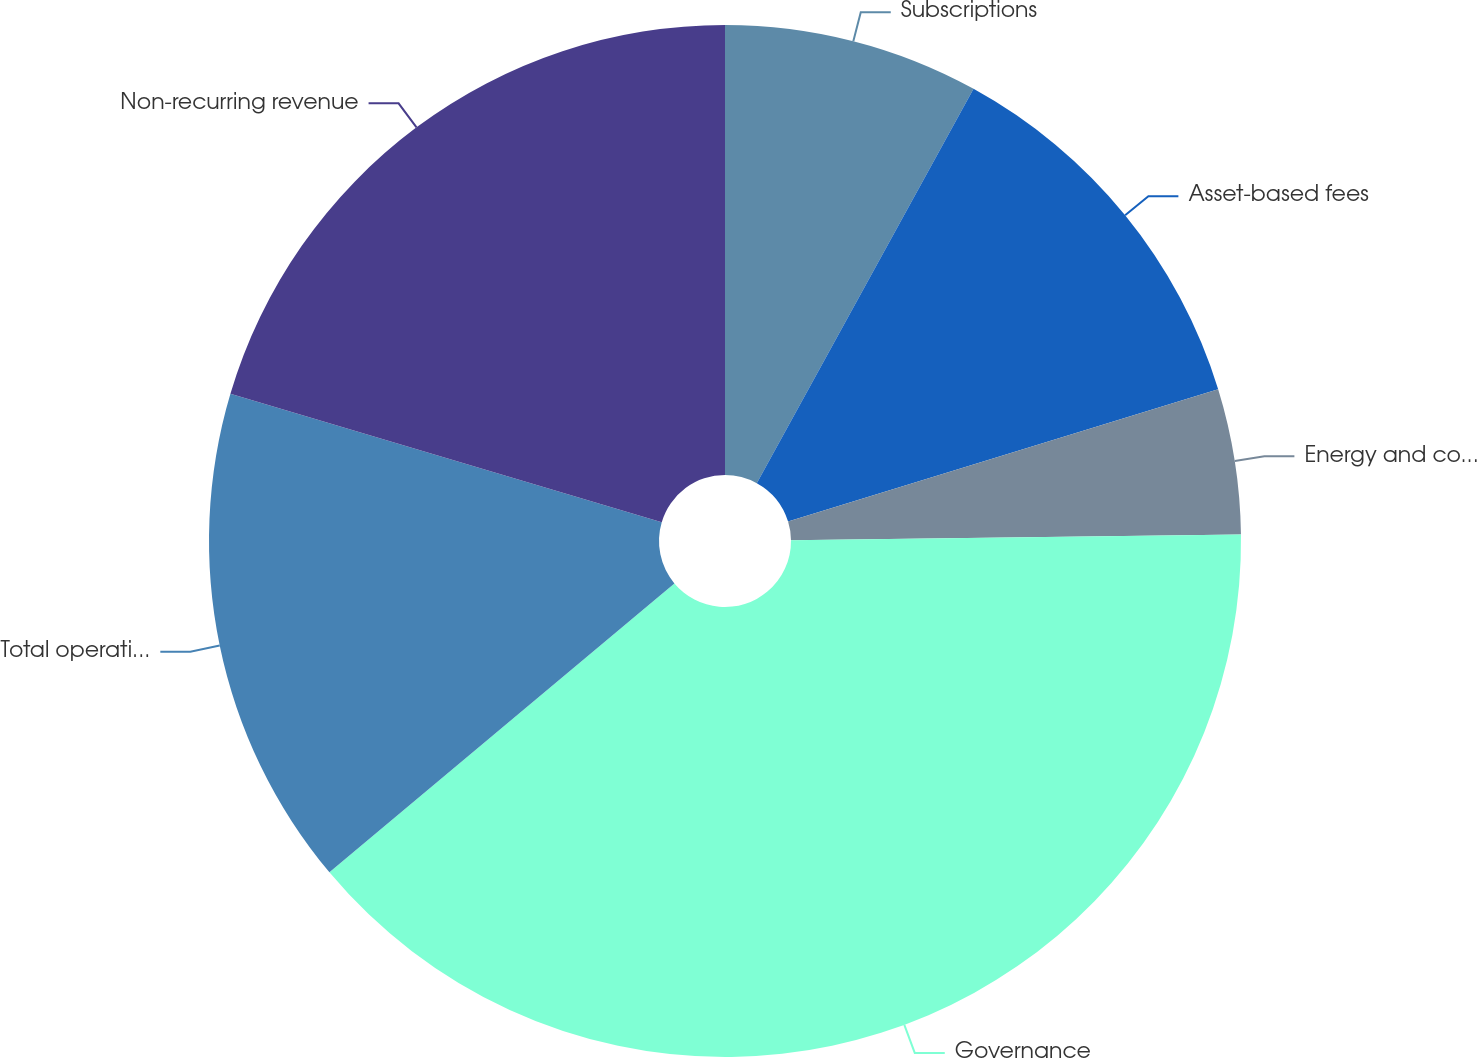Convert chart to OTSL. <chart><loc_0><loc_0><loc_500><loc_500><pie_chart><fcel>Subscriptions<fcel>Asset-based fees<fcel>Energy and commodity analytics<fcel>Governance<fcel>Total operating revenues<fcel>Non-recurring revenue<nl><fcel>8.0%<fcel>12.25%<fcel>4.55%<fcel>39.11%<fcel>15.7%<fcel>20.4%<nl></chart> 